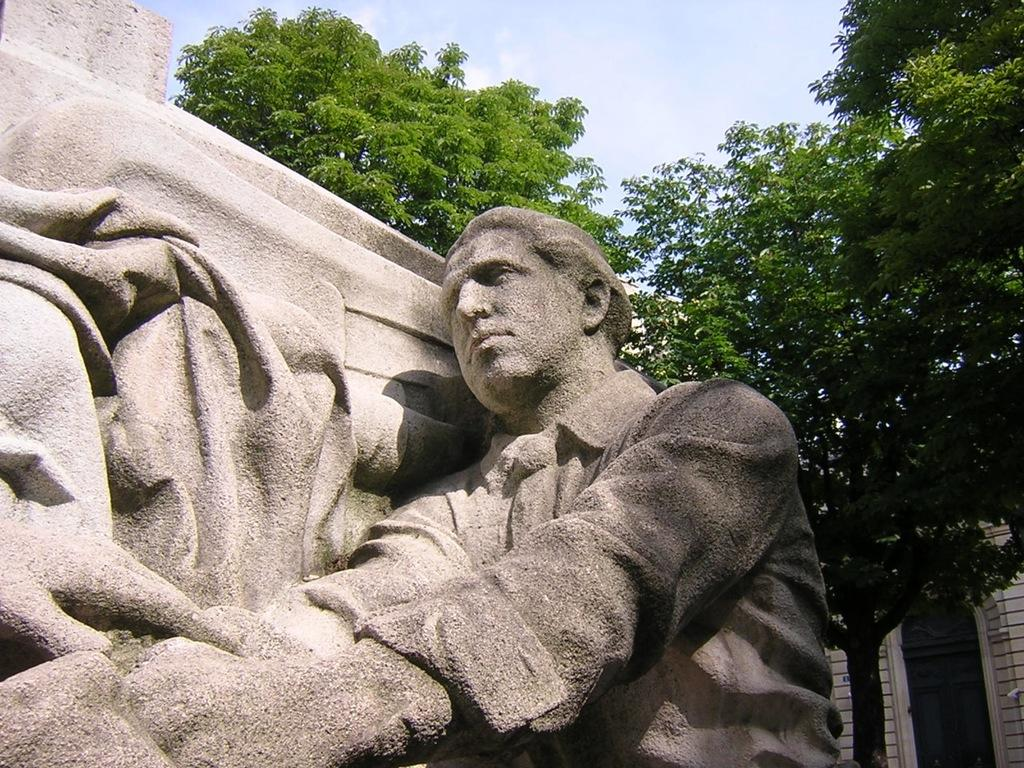Who or what is present in the image? There is a person in the image. What is located beside the person? There is a wall beside the person. What can be seen in the background of the image? There are trees and a building in the background of the image. How many vests can be seen on the person in the image? There is no mention of a vest in the image, so it cannot be determined if any vests are present. 